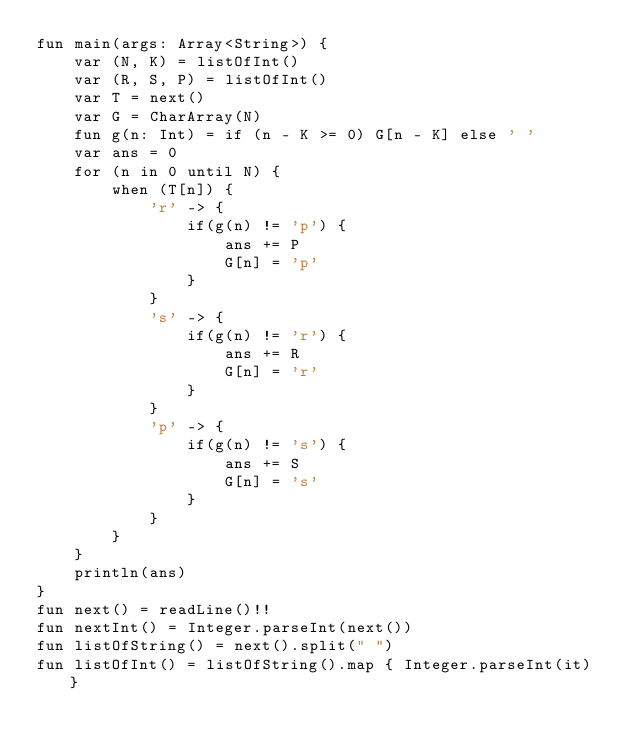<code> <loc_0><loc_0><loc_500><loc_500><_Kotlin_>fun main(args: Array<String>) {
    var (N, K) = listOfInt()
    var (R, S, P) = listOfInt()
    var T = next()
    var G = CharArray(N)
    fun g(n: Int) = if (n - K >= 0) G[n - K] else ' '
    var ans = 0
    for (n in 0 until N) {
        when (T[n]) {
            'r' -> {
                if(g(n) != 'p') {
                    ans += P
                    G[n] = 'p'
                }
            }
            's' -> {
                if(g(n) != 'r') {
                    ans += R
                    G[n] = 'r'
                }
            }
            'p' -> {
                if(g(n) != 's') {
                    ans += S
                    G[n] = 's'
                }
            }
        }
    }
    println(ans)
}
fun next() = readLine()!!
fun nextInt() = Integer.parseInt(next())
fun listOfString() = next().split(" ")
fun listOfInt() = listOfString().map { Integer.parseInt(it) }
</code> 